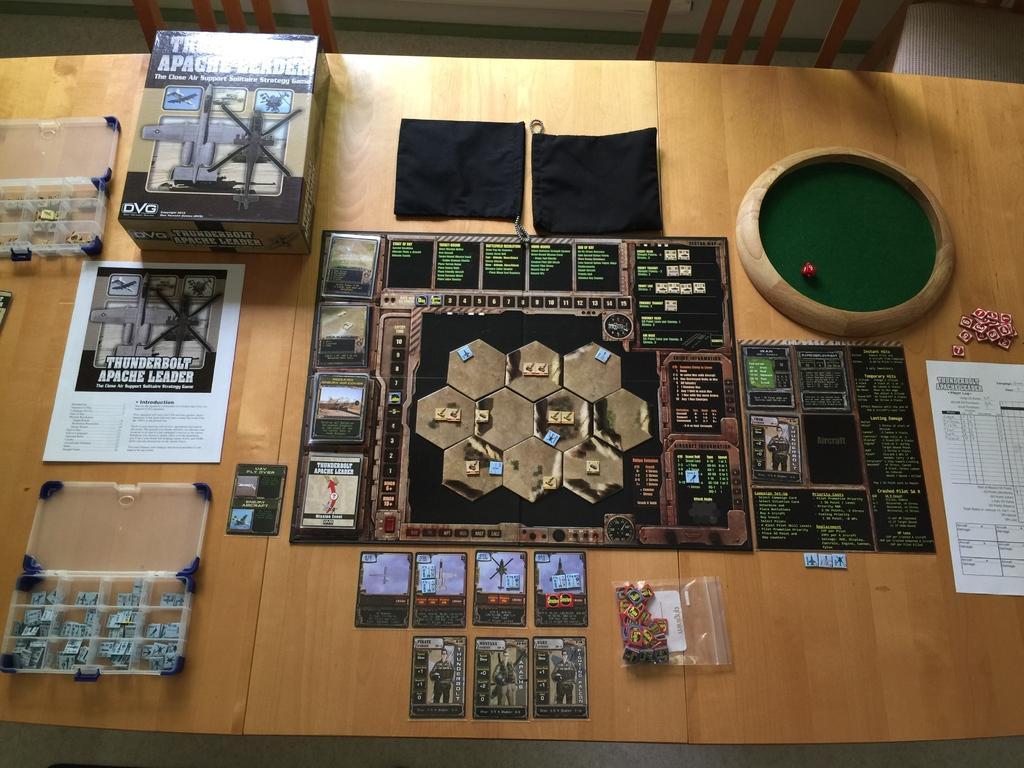Please provide a concise description of this image. In this picture I can see a game called "Thunderbolt Apache leader" on the tables and I can see a couple of boxes with coins and papers and couple of small bags and Cards and a wooden ball with dice and few coins on the side and I can see couple of chairs 